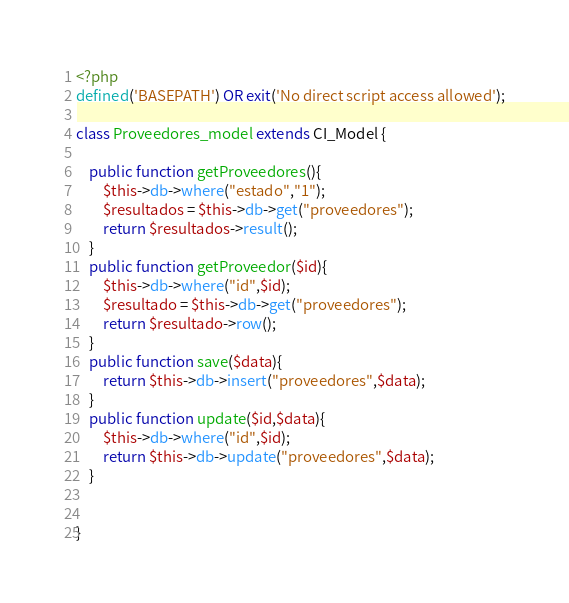<code> <loc_0><loc_0><loc_500><loc_500><_PHP_><?php
defined('BASEPATH') OR exit('No direct script access allowed');

class Proveedores_model extends CI_Model {

	public function getProveedores(){
		$this->db->where("estado","1");
		$resultados = $this->db->get("proveedores");
		return $resultados->result();
	}
	public function getProveedor($id){
		$this->db->where("id",$id);
		$resultado = $this->db->get("proveedores");
		return $resultado->row();
	}
	public function save($data){
		return $this->db->insert("proveedores",$data);
	}
	public function update($id,$data){
		$this->db->where("id",$id);
		return $this->db->update("proveedores",$data);
	}

	
}</code> 